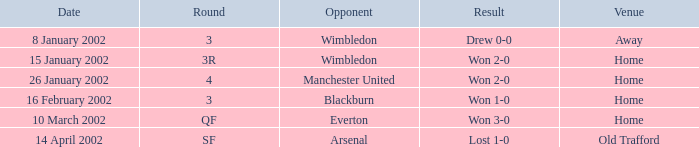What is the Date with a Round with sf? 14 April 2002. 